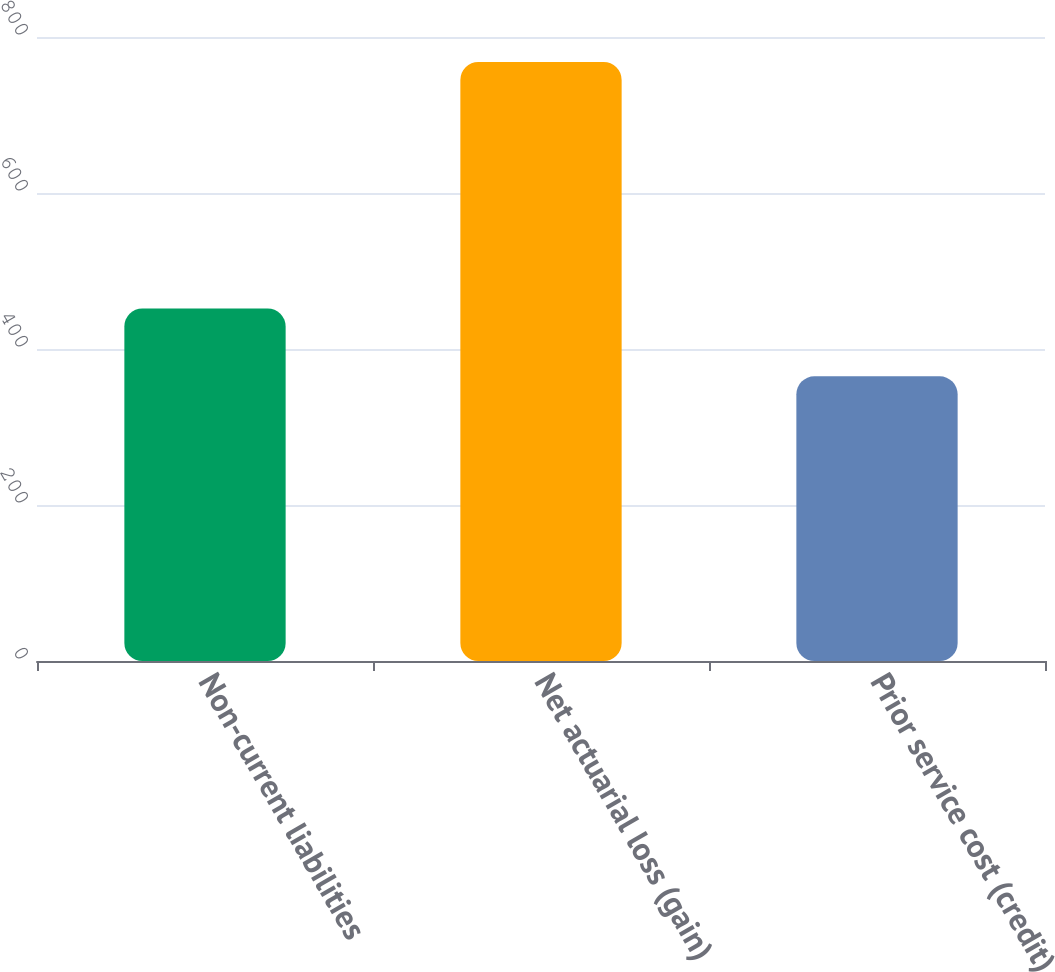<chart> <loc_0><loc_0><loc_500><loc_500><bar_chart><fcel>Non-current liabilities<fcel>Net actuarial loss (gain)<fcel>Prior service cost (credit)<nl><fcel>452<fcel>768<fcel>365<nl></chart> 